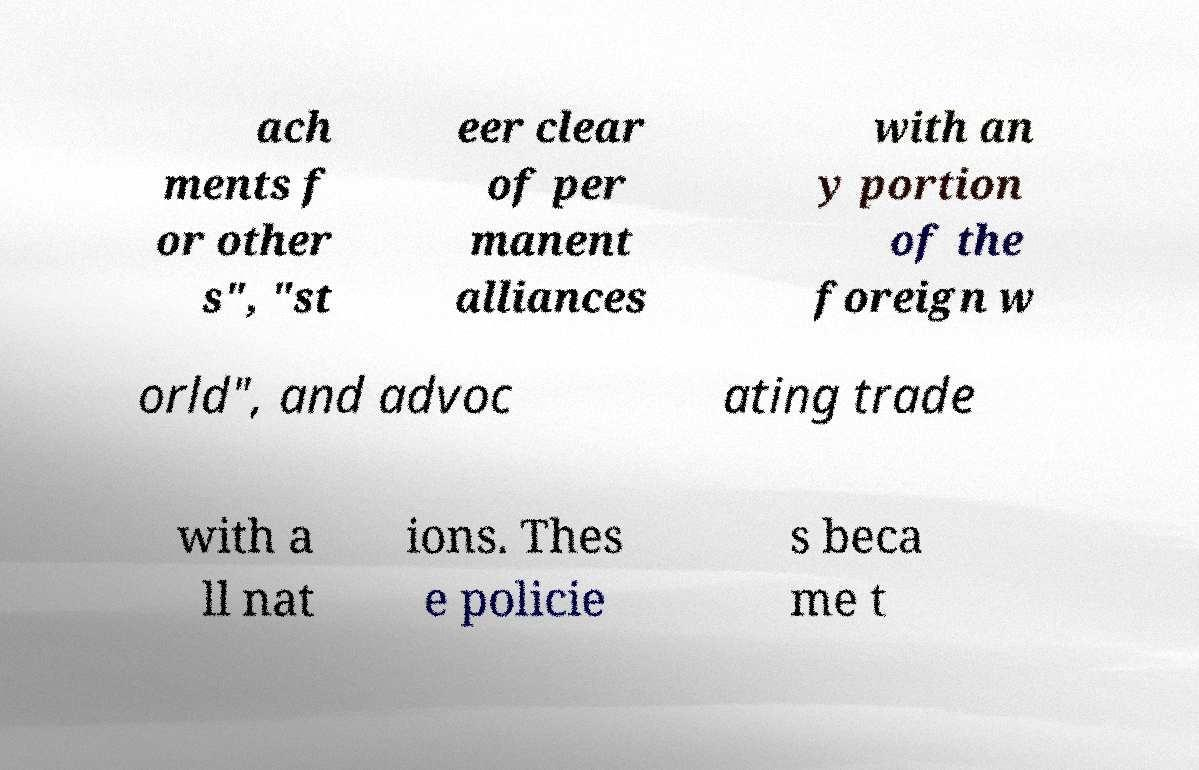I need the written content from this picture converted into text. Can you do that? ach ments f or other s", "st eer clear of per manent alliances with an y portion of the foreign w orld", and advoc ating trade with a ll nat ions. Thes e policie s beca me t 